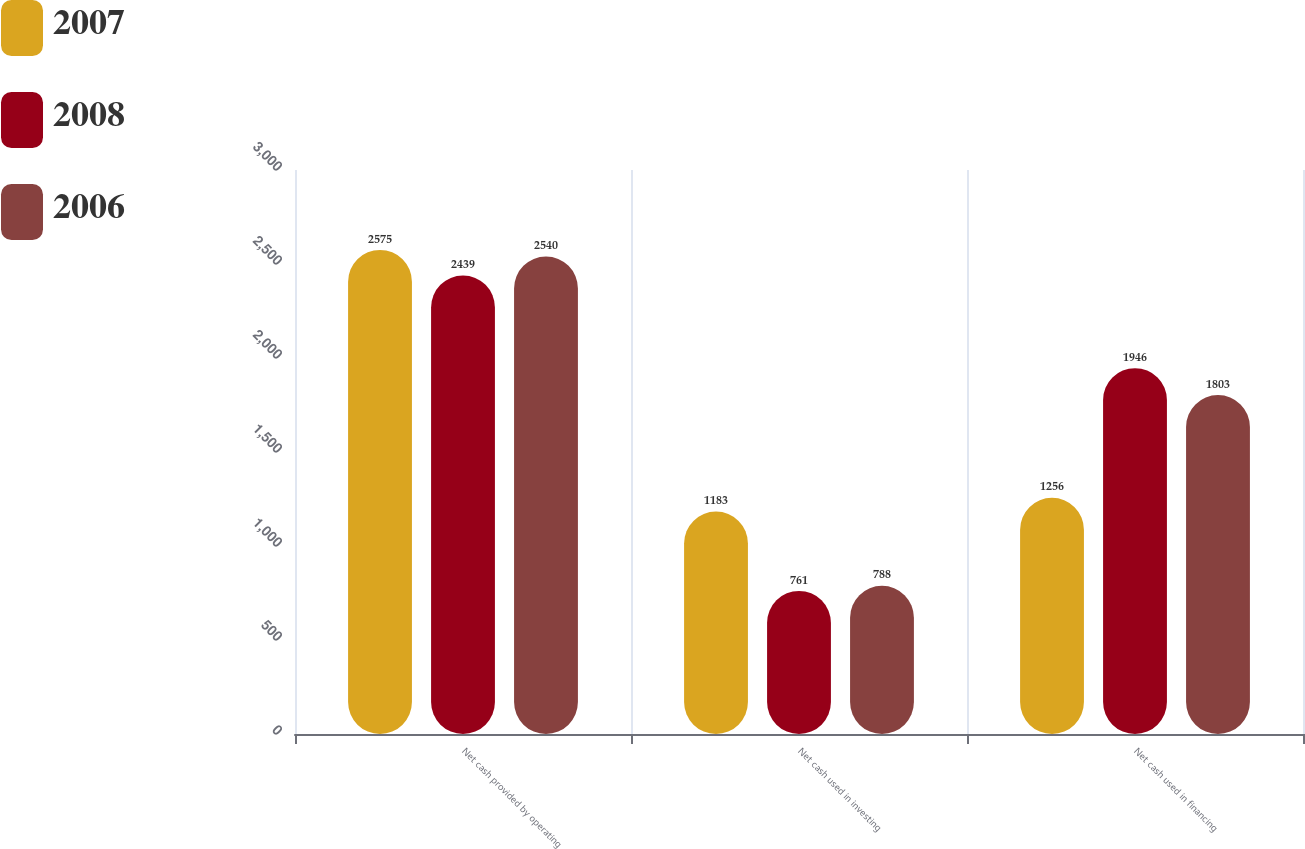<chart> <loc_0><loc_0><loc_500><loc_500><stacked_bar_chart><ecel><fcel>Net cash provided by operating<fcel>Net cash used in investing<fcel>Net cash used in financing<nl><fcel>2007<fcel>2575<fcel>1183<fcel>1256<nl><fcel>2008<fcel>2439<fcel>761<fcel>1946<nl><fcel>2006<fcel>2540<fcel>788<fcel>1803<nl></chart> 